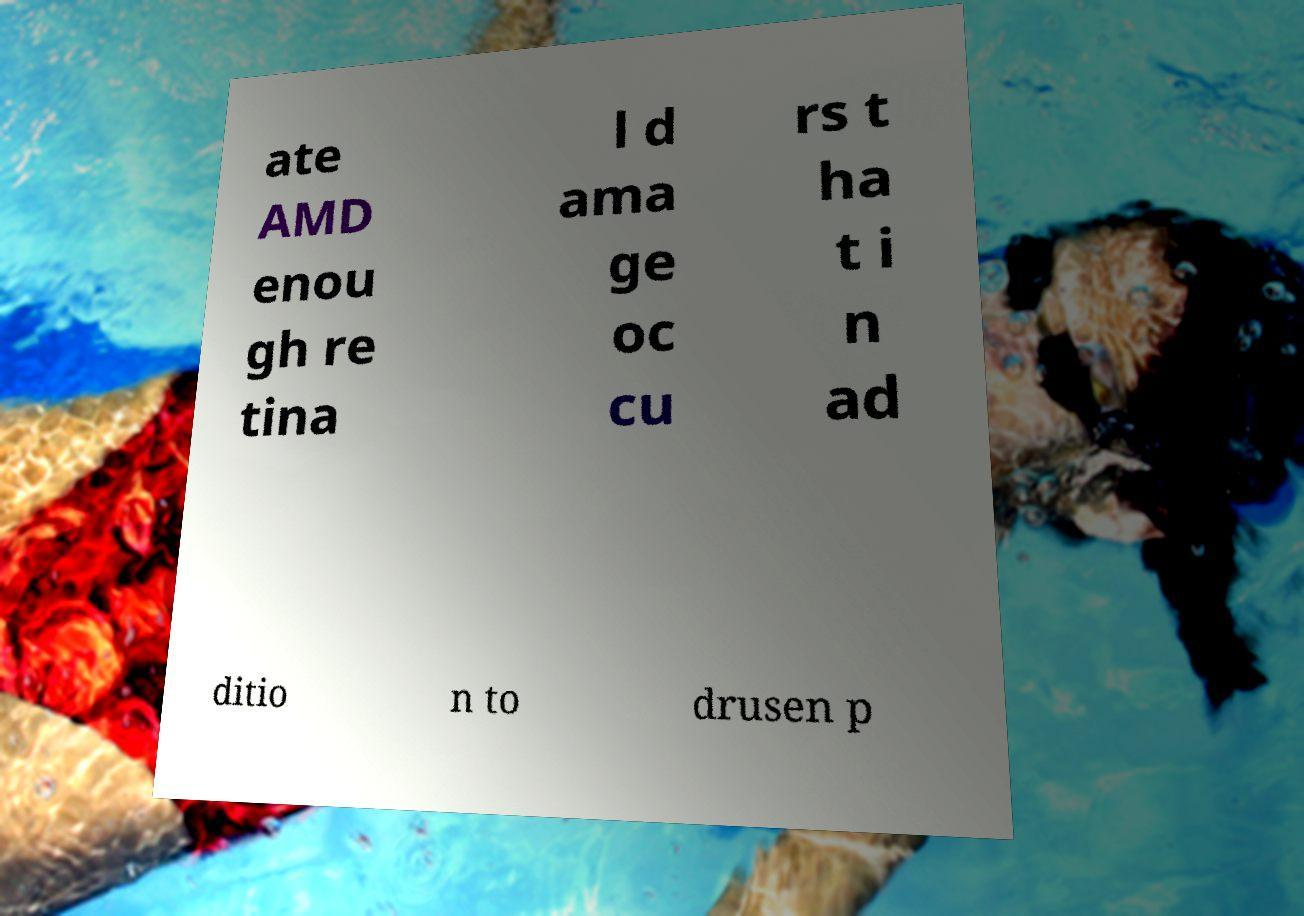Could you extract and type out the text from this image? ate AMD enou gh re tina l d ama ge oc cu rs t ha t i n ad ditio n to drusen p 